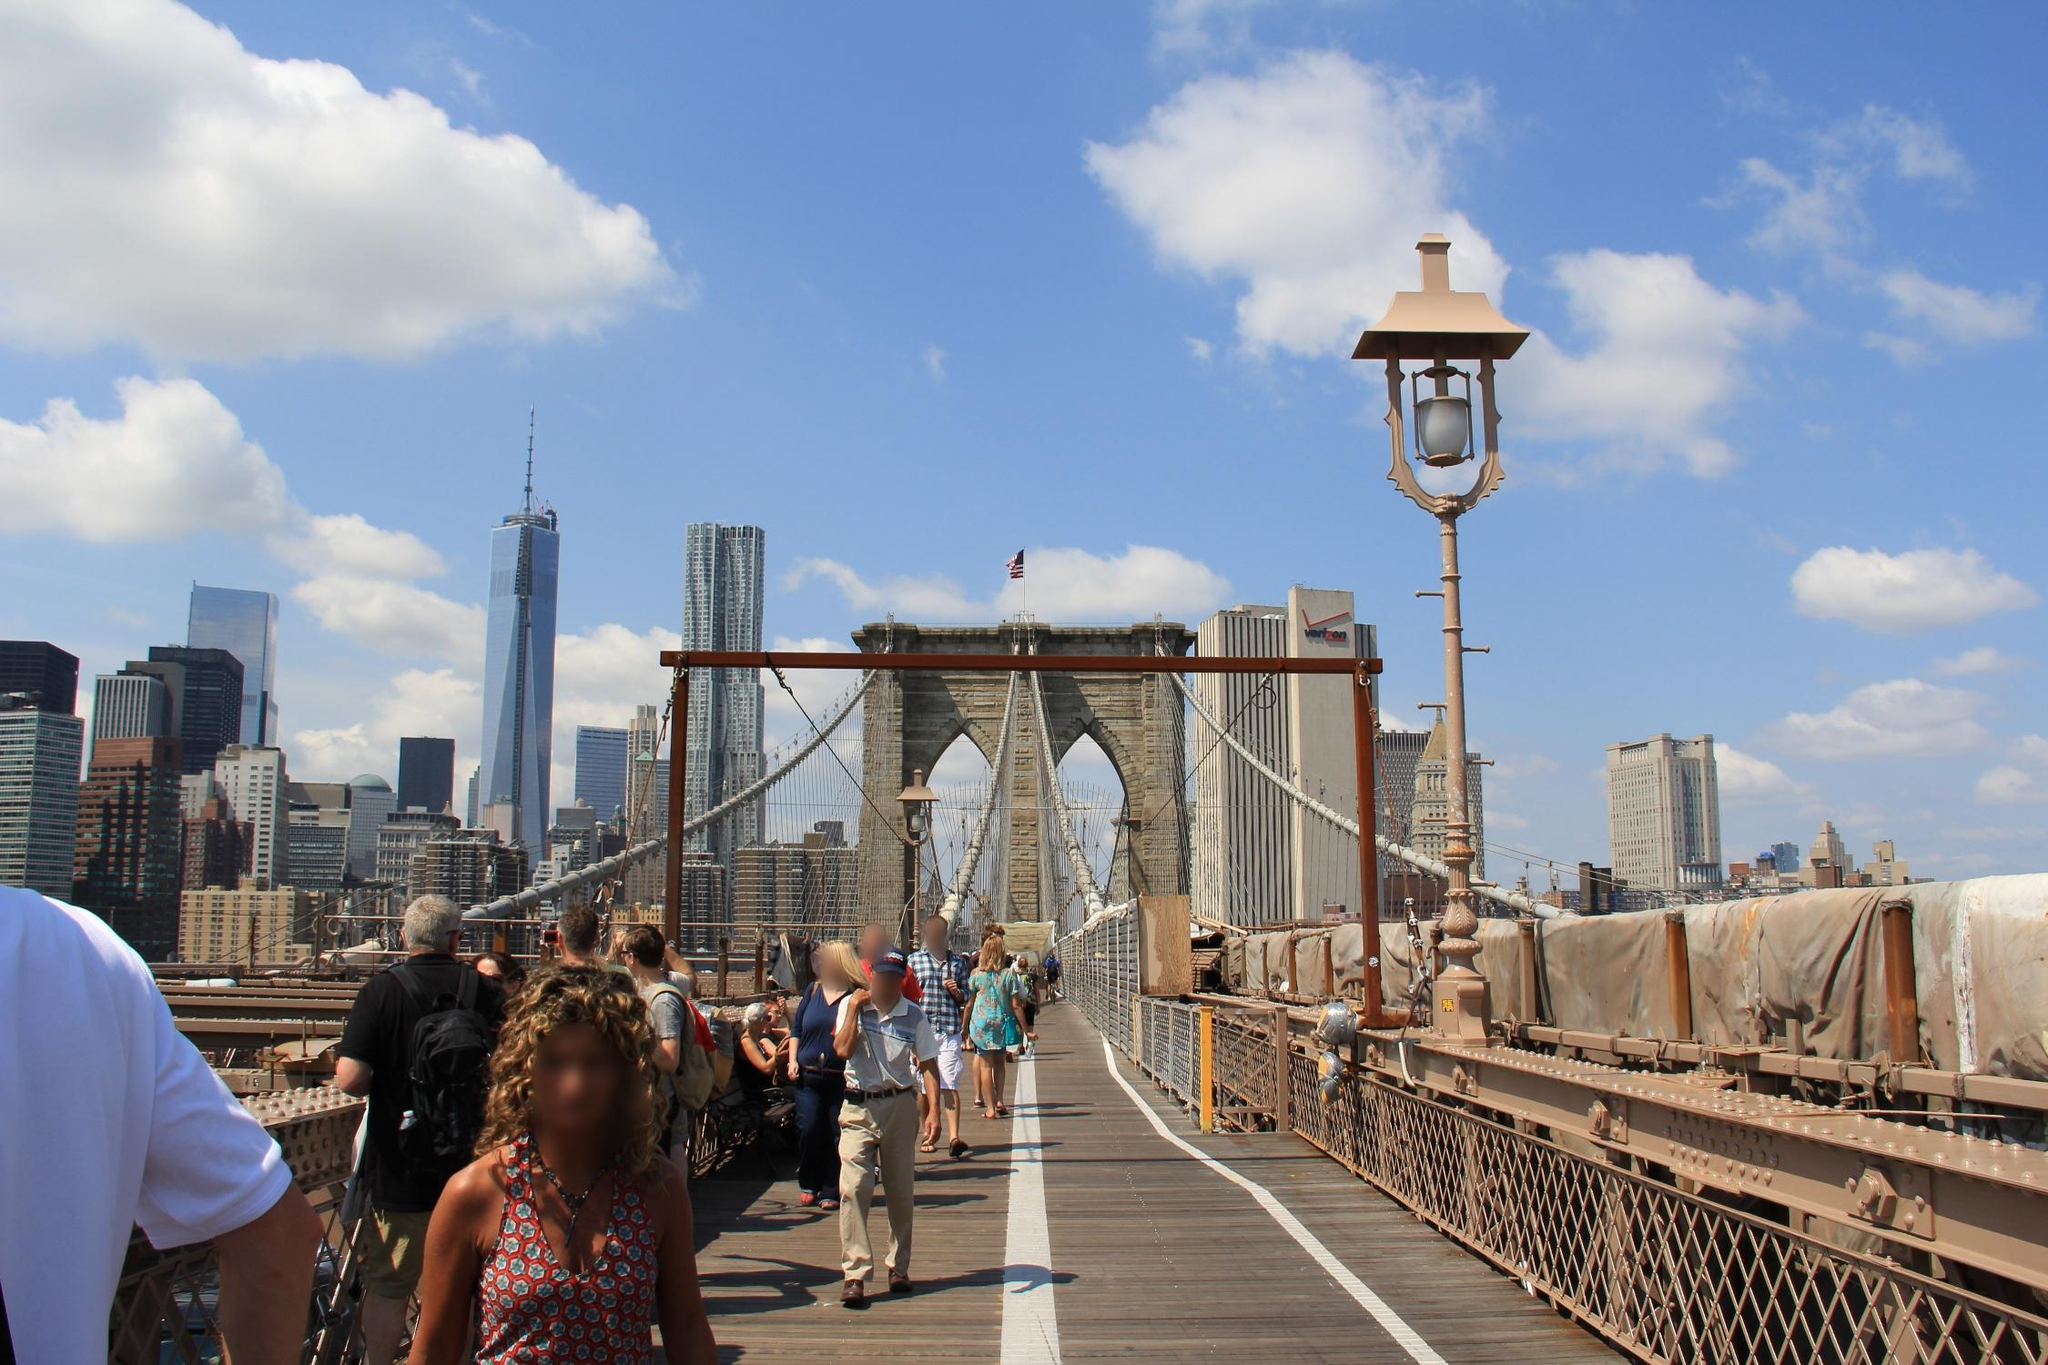Analyze the image in a comprehensive and detailed manner. The image provides an impressive view of the iconic Brooklyn Bridge in New York City. Taken from the pedestrian walkway, it offers a perspective facing towards the Manhattan skyline. The Brooklyn Bridge, an engineering masterpiece of the 19th century, is distinguished by its Gothic-style arches built of limestone, granite, and cement. The two arches, standing tall, create a striking framework under which the walkway, made of wooden planks, extends forward. Interconnecting these arches are numerous steel cables that form intricate patterns against the azure sky. Safety railings line the walkway, and vintage-style lampposts are positioned intermittently, merging historical charm with a modern metropolis. Couples, tourists, and pedestrians are seen strolling, adding a dynamic human element to the scene. The skyline in the background showcases some of Manhattan's tallest skyscrapers, including the towering One World Trade Center, standing as a symbol of resilience. The weather is bright and sunny, with sparse clouds dotting the sky, enhancing the overall warmth and welcoming atmosphere of the photograph. The composition beautifully marries the historic grandeur of the Brooklyn Bridge with the contemporary splendor of New York's skyline. 